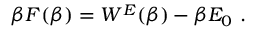Convert formula to latex. <formula><loc_0><loc_0><loc_500><loc_500>\beta F ( \beta ) = W ^ { E } ( \beta ) - \beta E _ { 0 } .</formula> 